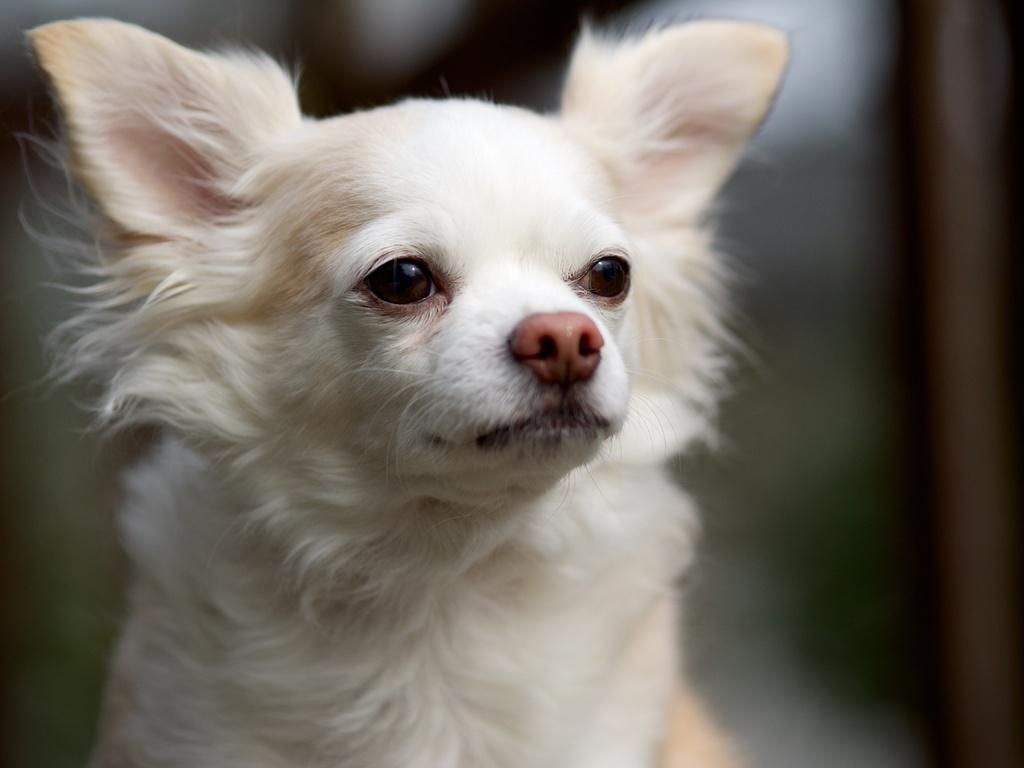What type of animal is in the picture? There is a white dog in the picture. Can you describe the background of the image? The background of the image is blurred. What type of whistle can be heard in the image? There is no whistle present in the image, as it is a still picture of a white dog. 